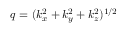Convert formula to latex. <formula><loc_0><loc_0><loc_500><loc_500>q = ( k _ { x } ^ { 2 } + k _ { y } ^ { 2 } + k _ { z } ^ { 2 } ) ^ { 1 / 2 }</formula> 